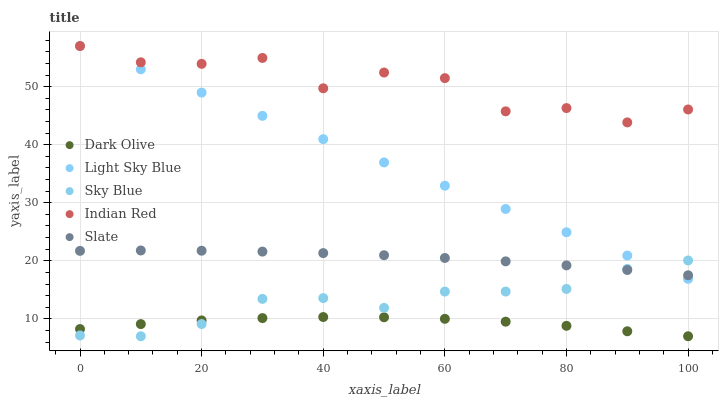Does Dark Olive have the minimum area under the curve?
Answer yes or no. Yes. Does Indian Red have the maximum area under the curve?
Answer yes or no. Yes. Does Slate have the minimum area under the curve?
Answer yes or no. No. Does Slate have the maximum area under the curve?
Answer yes or no. No. Is Light Sky Blue the smoothest?
Answer yes or no. Yes. Is Indian Red the roughest?
Answer yes or no. Yes. Is Slate the smoothest?
Answer yes or no. No. Is Slate the roughest?
Answer yes or no. No. Does Sky Blue have the lowest value?
Answer yes or no. Yes. Does Slate have the lowest value?
Answer yes or no. No. Does Light Sky Blue have the highest value?
Answer yes or no. Yes. Does Slate have the highest value?
Answer yes or no. No. Is Dark Olive less than Light Sky Blue?
Answer yes or no. Yes. Is Light Sky Blue greater than Dark Olive?
Answer yes or no. Yes. Does Sky Blue intersect Slate?
Answer yes or no. Yes. Is Sky Blue less than Slate?
Answer yes or no. No. Is Sky Blue greater than Slate?
Answer yes or no. No. Does Dark Olive intersect Light Sky Blue?
Answer yes or no. No. 